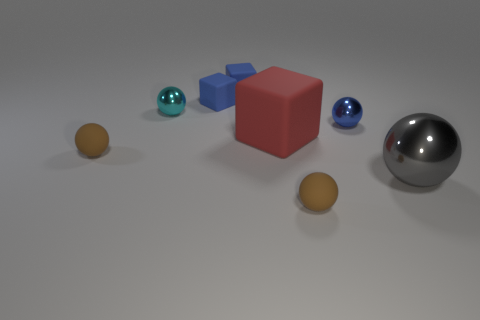Subtract all yellow balls. Subtract all purple cylinders. How many balls are left? 5 Add 1 tiny blue cubes. How many objects exist? 9 Subtract all cubes. How many objects are left? 5 Subtract 0 red balls. How many objects are left? 8 Subtract all blue metal objects. Subtract all brown matte spheres. How many objects are left? 5 Add 1 cyan shiny things. How many cyan shiny things are left? 2 Add 4 brown objects. How many brown objects exist? 6 